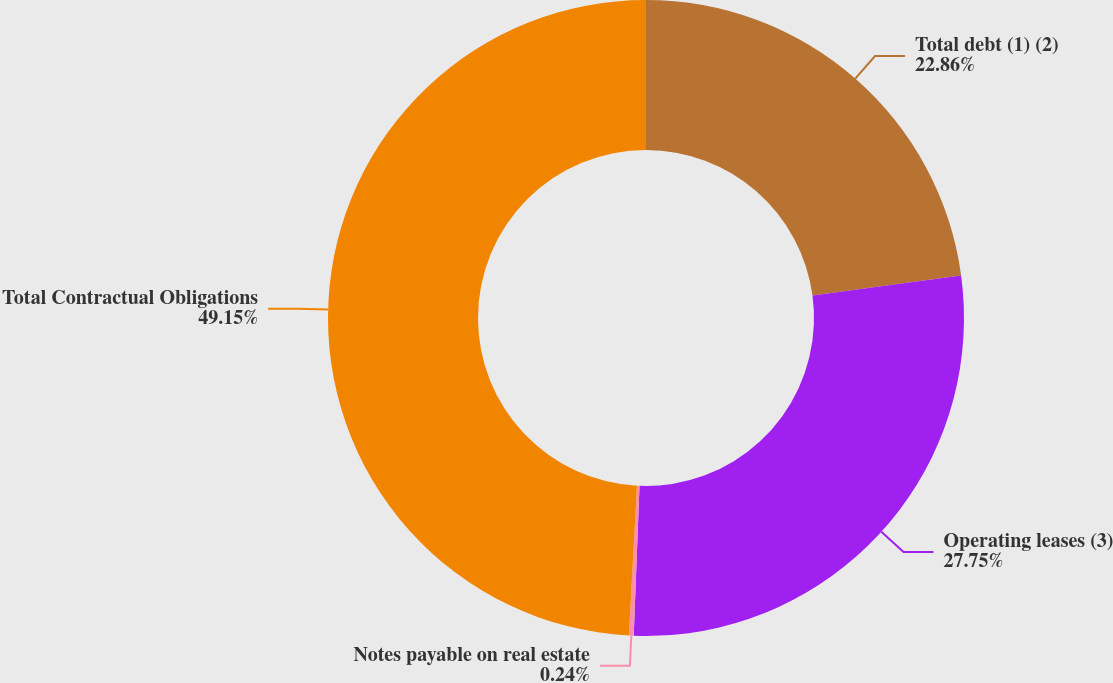<chart> <loc_0><loc_0><loc_500><loc_500><pie_chart><fcel>Total debt (1) (2)<fcel>Operating leases (3)<fcel>Notes payable on real estate<fcel>Total Contractual Obligations<nl><fcel>22.86%<fcel>27.75%<fcel>0.24%<fcel>49.14%<nl></chart> 